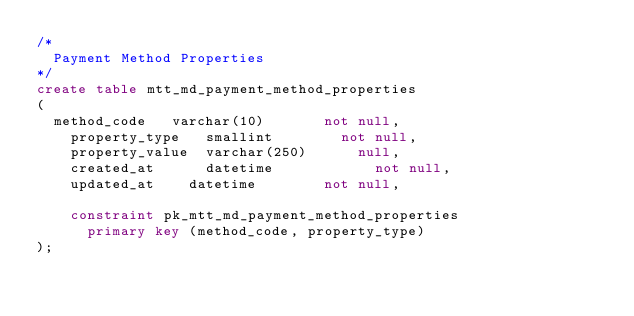Convert code to text. <code><loc_0><loc_0><loc_500><loc_500><_SQL_>/*
	Payment Method Properties
*/
create table mtt_md_payment_method_properties
(
	method_code 	varchar(10) 	    not null,
    property_type 	smallint 		    not null,
    property_value 	varchar(250)	    null,
    created_at      datetime            not null, 
    updated_at 		datetime 		    not null,

    constraint pk_mtt_md_payment_method_properties
	    primary key (method_code, property_type)
);
</code> 